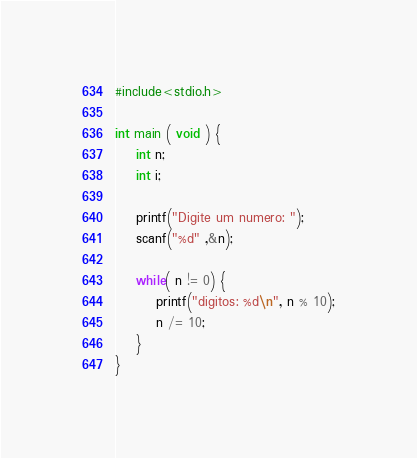Convert code to text. <code><loc_0><loc_0><loc_500><loc_500><_C_>#include<stdio.h>

int main ( void ) {
	int n;
	int i;
	
	printf("Digite um numero: ");
	scanf("%d" ,&n);
	
	while( n != 0) {
		printf("digitos: %d\n", n % 10);
		n /= 10;
	}	
}
</code> 